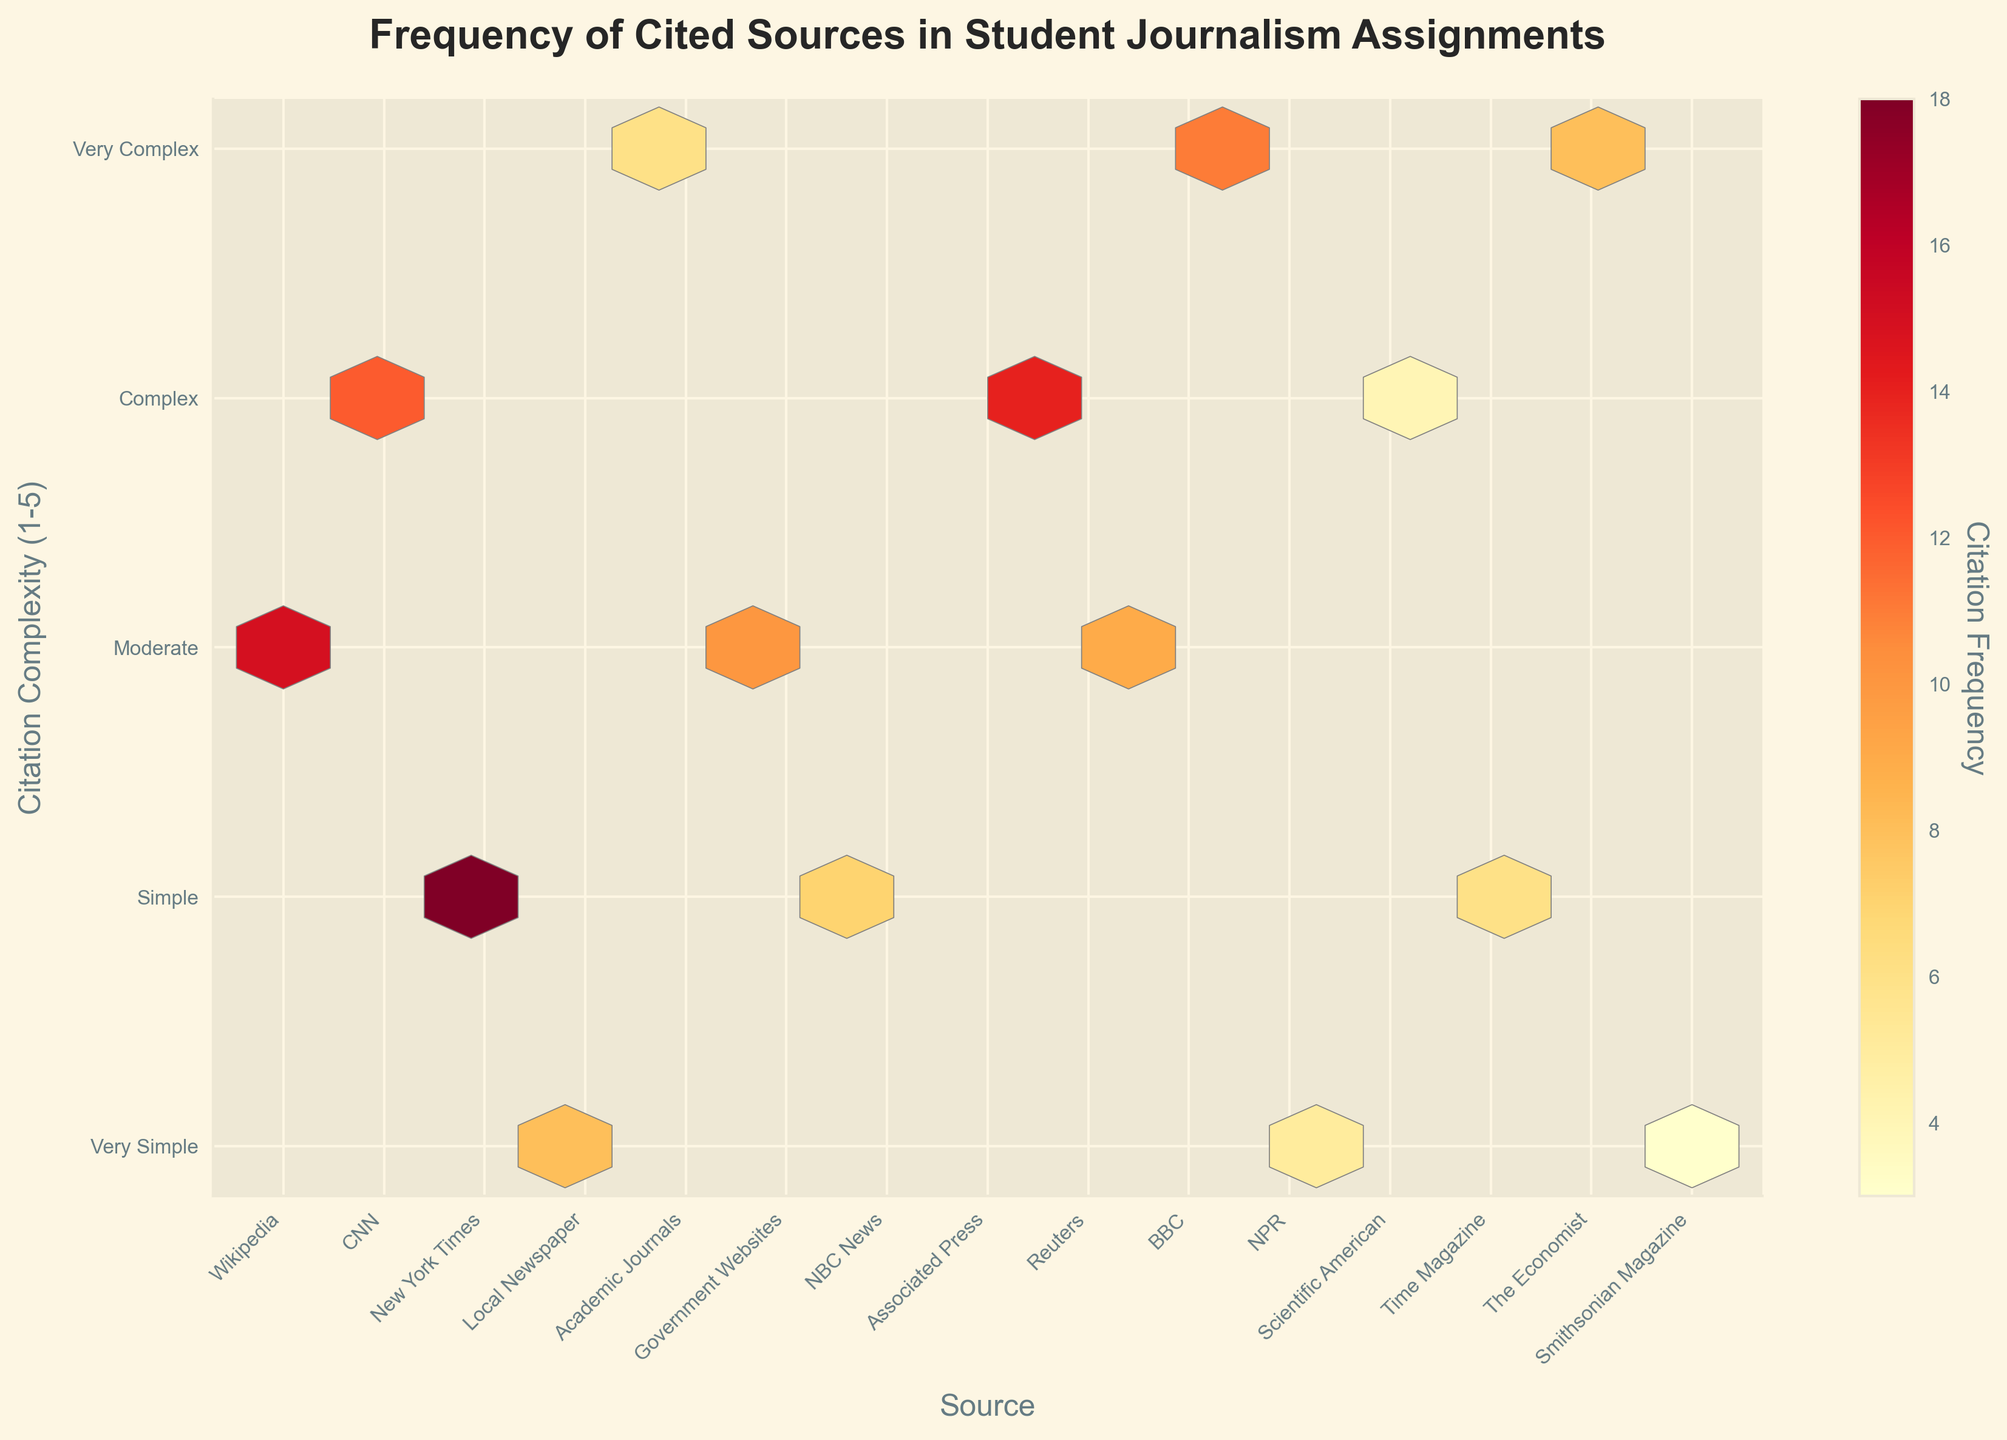What is the title of the figure? The title is usually placed at the top of the figure, and this one is no exception. It is bold and large, making it easy to identify.
Answer: Frequency of Cited Sources in Student Journalism Assignments Which source is cited the most in student assignments? The hexbin plot uses color intensity to represent citation frequency. The brightest hexbin represents New York Times with a citation count of 18.
Answer: New York Times Which source falls under the 'Very Complex' citation complexity level and has a moderate citation frequency? By looking at the y-axis labeled 'Citation Complexity' and the color-coded hexagons, Academic Journals with citation complexity level 5 and a frequency of 6 can be identified.
Answer: Academic Journals What is the citation frequency color range used in the plot? The color bar on the right indicates the frequency range from a lighter to a darker shade of the 'YlOrRd' color spectrum, from lowest to highest frequency.
Answer: Light to dark shades of yellow, orange, and red How does the citation frequency of CNN compare to that of Wikipedia? By comparing the colors of the hexagons corresponding to CNN and Wikipedia, it can be observed that CNN (12) has a darker, therefore higher citation frequency than Wikipedia (15).
Answer: Wikipedia is cited more often than CNN Which source with moderate complexity is cited more frequently: Government Websites or Reuters? Both sources are in the moderate complexity range (citation complexity level 3), but comparing their color intensities shows that Government Websites receive a frequency of 10, while Reuters receives a frequency of 9.
Answer: Government Websites How many sources fall under the 'Simple' citation complexity category? By counting the hexagons along the 'Simple' complexity level (y=2), there are five sources: New York Times, NBC News, Time Magazine, Associated Press, and Smithsonian Magazine.
Answer: 5 sources What is the least cited source for the 'Very Simple' citation complexity category? By examining the hexagons along the 'Very Simple' complexity level (y=1), the lightest colored hexagon represents Smithsonian Magazine with a citation frequency of 3.
Answer: Smithsonian Magazine Which source has a 'Very Complex' citation complexity, and how frequently is it cited compared to New York Times? Academic Journals is the only source with a 'Very Complex' label (y=5), and it has a citation frequency of 6. New York Times has a citation frequency of 18, which is much higher by 12.
Answer: Academic Journals is cited 12 times less frequently than New York Times Which source has the closest citation frequency to NPR and falls under the same complexity? NPR's citation complexity level is 1 and has a citation frequency of 5. Smithsonian Magazine, which also has a complexity level of 1, is close with a citation frequency of 3.
Answer: Smithsonian Magazine 